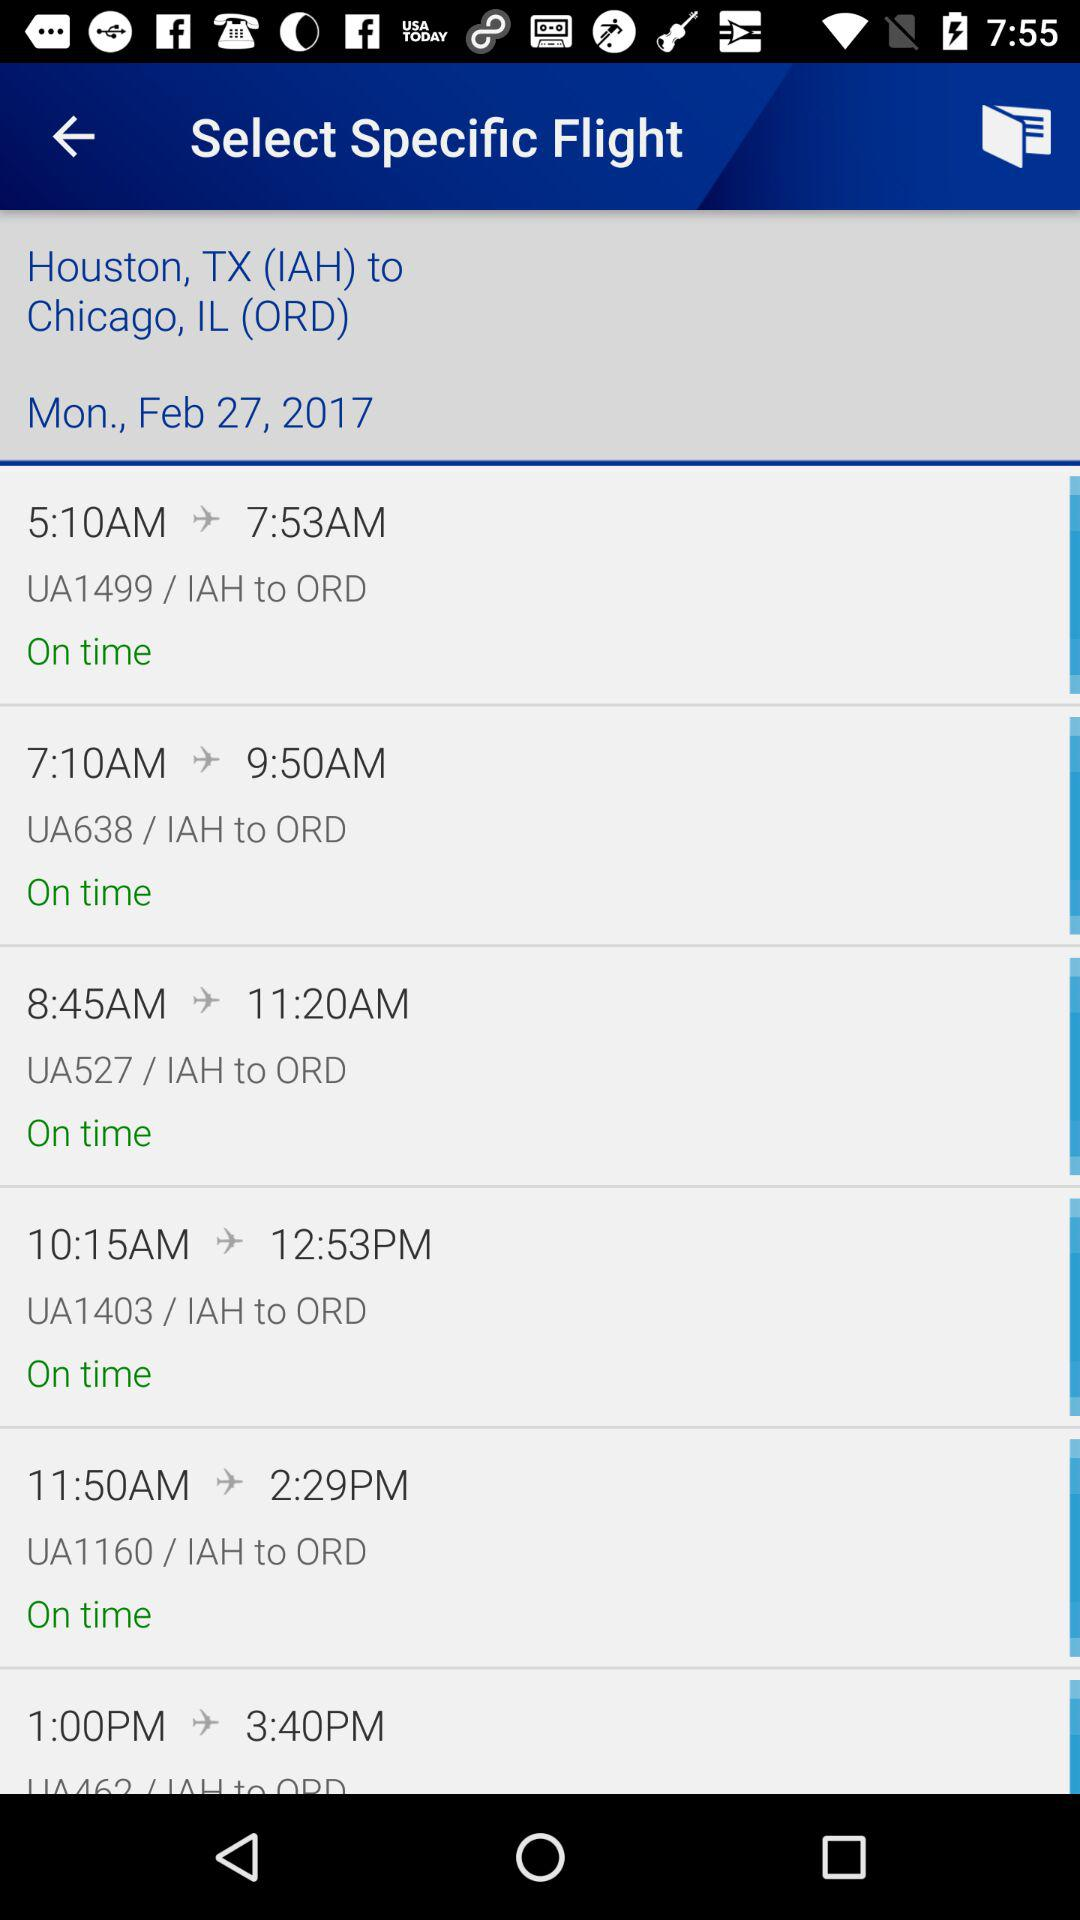How many flights are on time?
Answer the question using a single word or phrase. 5 